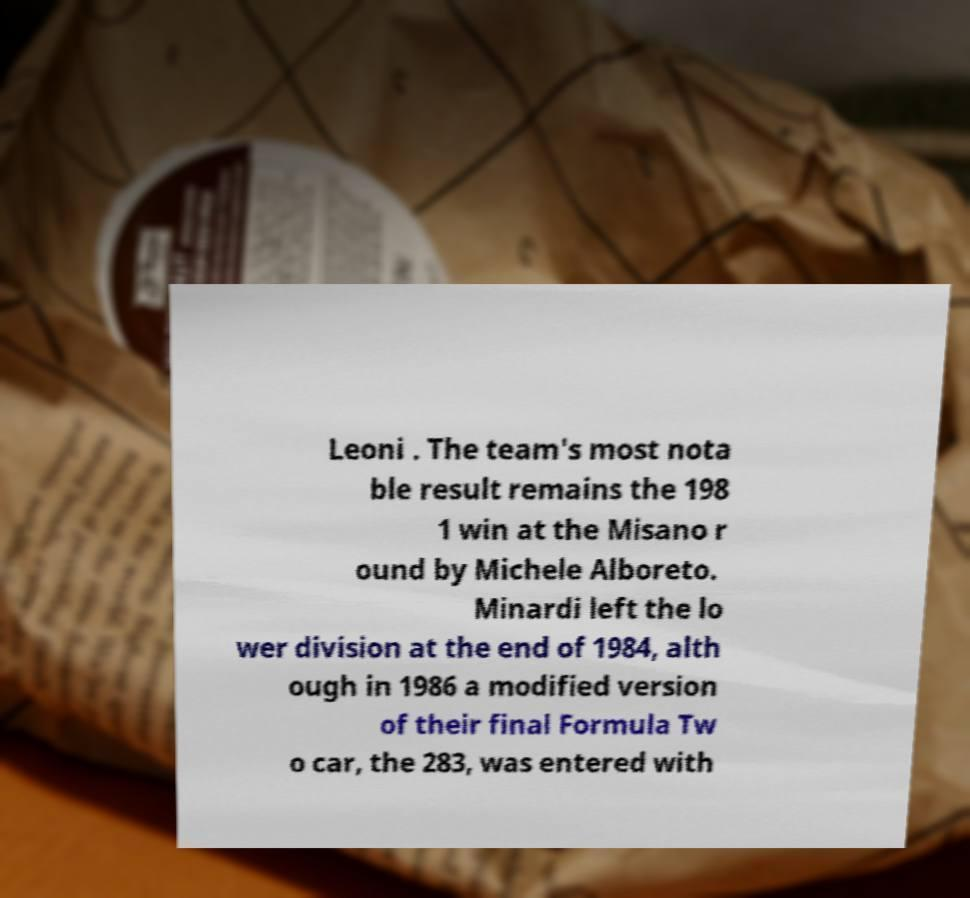For documentation purposes, I need the text within this image transcribed. Could you provide that? Leoni . The team's most nota ble result remains the 198 1 win at the Misano r ound by Michele Alboreto. Minardi left the lo wer division at the end of 1984, alth ough in 1986 a modified version of their final Formula Tw o car, the 283, was entered with 